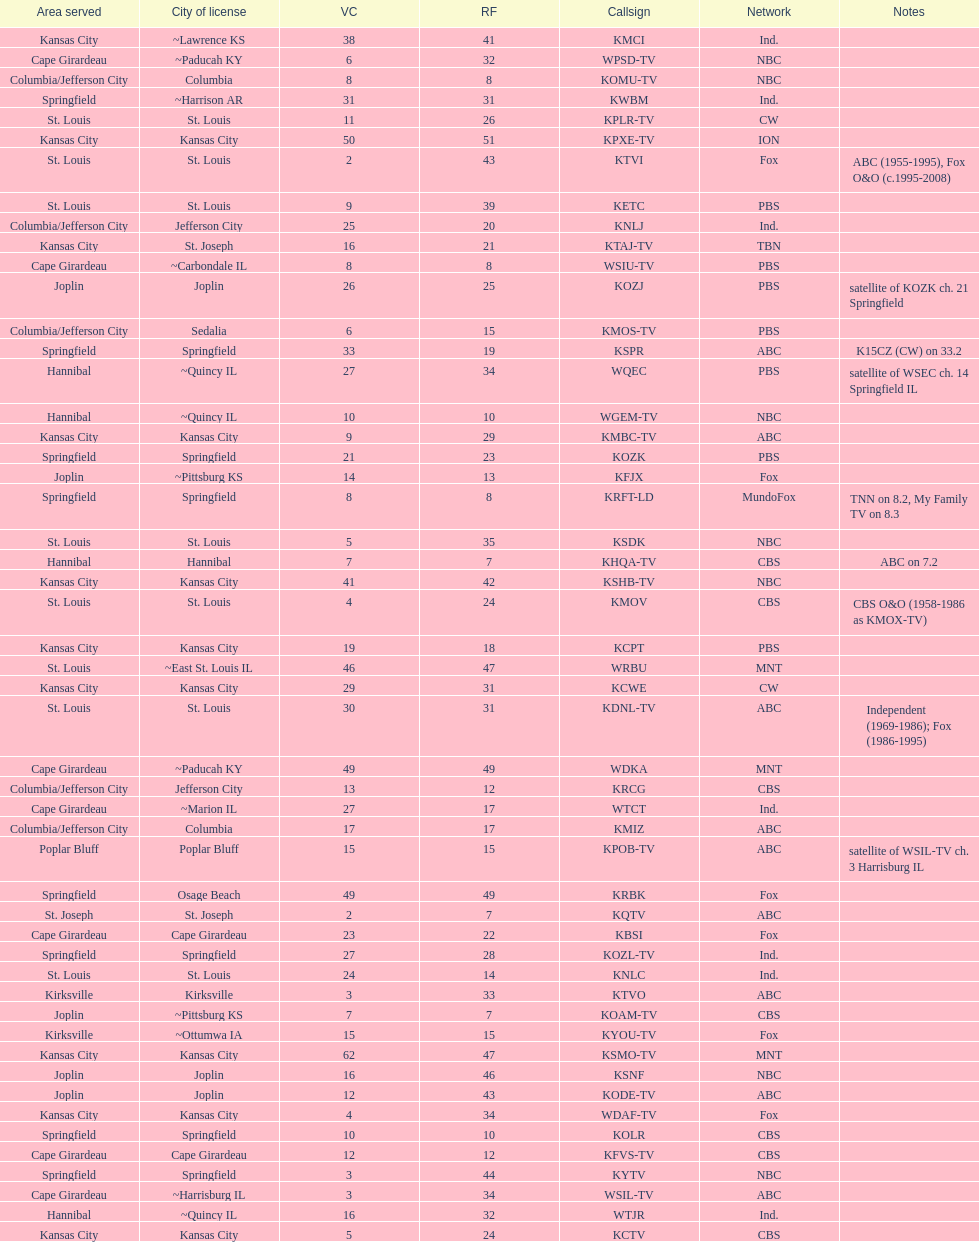How many of these missouri tv stations are actually licensed in a city in illinois (il)? 7. Could you help me parse every detail presented in this table? {'header': ['Area served', 'City of license', 'VC', 'RF', 'Callsign', 'Network', 'Notes'], 'rows': [['Kansas City', '~Lawrence KS', '38', '41', 'KMCI', 'Ind.', ''], ['Cape Girardeau', '~Paducah KY', '6', '32', 'WPSD-TV', 'NBC', ''], ['Columbia/Jefferson City', 'Columbia', '8', '8', 'KOMU-TV', 'NBC', ''], ['Springfield', '~Harrison AR', '31', '31', 'KWBM', 'Ind.', ''], ['St. Louis', 'St. Louis', '11', '26', 'KPLR-TV', 'CW', ''], ['Kansas City', 'Kansas City', '50', '51', 'KPXE-TV', 'ION', ''], ['St. Louis', 'St. Louis', '2', '43', 'KTVI', 'Fox', 'ABC (1955-1995), Fox O&O (c.1995-2008)'], ['St. Louis', 'St. Louis', '9', '39', 'KETC', 'PBS', ''], ['Columbia/Jefferson City', 'Jefferson City', '25', '20', 'KNLJ', 'Ind.', ''], ['Kansas City', 'St. Joseph', '16', '21', 'KTAJ-TV', 'TBN', ''], ['Cape Girardeau', '~Carbondale IL', '8', '8', 'WSIU-TV', 'PBS', ''], ['Joplin', 'Joplin', '26', '25', 'KOZJ', 'PBS', 'satellite of KOZK ch. 21 Springfield'], ['Columbia/Jefferson City', 'Sedalia', '6', '15', 'KMOS-TV', 'PBS', ''], ['Springfield', 'Springfield', '33', '19', 'KSPR', 'ABC', 'K15CZ (CW) on 33.2'], ['Hannibal', '~Quincy IL', '27', '34', 'WQEC', 'PBS', 'satellite of WSEC ch. 14 Springfield IL'], ['Hannibal', '~Quincy IL', '10', '10', 'WGEM-TV', 'NBC', ''], ['Kansas City', 'Kansas City', '9', '29', 'KMBC-TV', 'ABC', ''], ['Springfield', 'Springfield', '21', '23', 'KOZK', 'PBS', ''], ['Joplin', '~Pittsburg KS', '14', '13', 'KFJX', 'Fox', ''], ['Springfield', 'Springfield', '8', '8', 'KRFT-LD', 'MundoFox', 'TNN on 8.2, My Family TV on 8.3'], ['St. Louis', 'St. Louis', '5', '35', 'KSDK', 'NBC', ''], ['Hannibal', 'Hannibal', '7', '7', 'KHQA-TV', 'CBS', 'ABC on 7.2'], ['Kansas City', 'Kansas City', '41', '42', 'KSHB-TV', 'NBC', ''], ['St. Louis', 'St. Louis', '4', '24', 'KMOV', 'CBS', 'CBS O&O (1958-1986 as KMOX-TV)'], ['Kansas City', 'Kansas City', '19', '18', 'KCPT', 'PBS', ''], ['St. Louis', '~East St. Louis IL', '46', '47', 'WRBU', 'MNT', ''], ['Kansas City', 'Kansas City', '29', '31', 'KCWE', 'CW', ''], ['St. Louis', 'St. Louis', '30', '31', 'KDNL-TV', 'ABC', 'Independent (1969-1986); Fox (1986-1995)'], ['Cape Girardeau', '~Paducah KY', '49', '49', 'WDKA', 'MNT', ''], ['Columbia/Jefferson City', 'Jefferson City', '13', '12', 'KRCG', 'CBS', ''], ['Cape Girardeau', '~Marion IL', '27', '17', 'WTCT', 'Ind.', ''], ['Columbia/Jefferson City', 'Columbia', '17', '17', 'KMIZ', 'ABC', ''], ['Poplar Bluff', 'Poplar Bluff', '15', '15', 'KPOB-TV', 'ABC', 'satellite of WSIL-TV ch. 3 Harrisburg IL'], ['Springfield', 'Osage Beach', '49', '49', 'KRBK', 'Fox', ''], ['St. Joseph', 'St. Joseph', '2', '7', 'KQTV', 'ABC', ''], ['Cape Girardeau', 'Cape Girardeau', '23', '22', 'KBSI', 'Fox', ''], ['Springfield', 'Springfield', '27', '28', 'KOZL-TV', 'Ind.', ''], ['St. Louis', 'St. Louis', '24', '14', 'KNLC', 'Ind.', ''], ['Kirksville', 'Kirksville', '3', '33', 'KTVO', 'ABC', ''], ['Joplin', '~Pittsburg KS', '7', '7', 'KOAM-TV', 'CBS', ''], ['Kirksville', '~Ottumwa IA', '15', '15', 'KYOU-TV', 'Fox', ''], ['Kansas City', 'Kansas City', '62', '47', 'KSMO-TV', 'MNT', ''], ['Joplin', 'Joplin', '16', '46', 'KSNF', 'NBC', ''], ['Joplin', 'Joplin', '12', '43', 'KODE-TV', 'ABC', ''], ['Kansas City', 'Kansas City', '4', '34', 'WDAF-TV', 'Fox', ''], ['Springfield', 'Springfield', '10', '10', 'KOLR', 'CBS', ''], ['Cape Girardeau', 'Cape Girardeau', '12', '12', 'KFVS-TV', 'CBS', ''], ['Springfield', 'Springfield', '3', '44', 'KYTV', 'NBC', ''], ['Cape Girardeau', '~Harrisburg IL', '3', '34', 'WSIL-TV', 'ABC', ''], ['Hannibal', '~Quincy IL', '16', '32', 'WTJR', 'Ind.', ''], ['Kansas City', 'Kansas City', '5', '24', 'KCTV', 'CBS', '']]} 